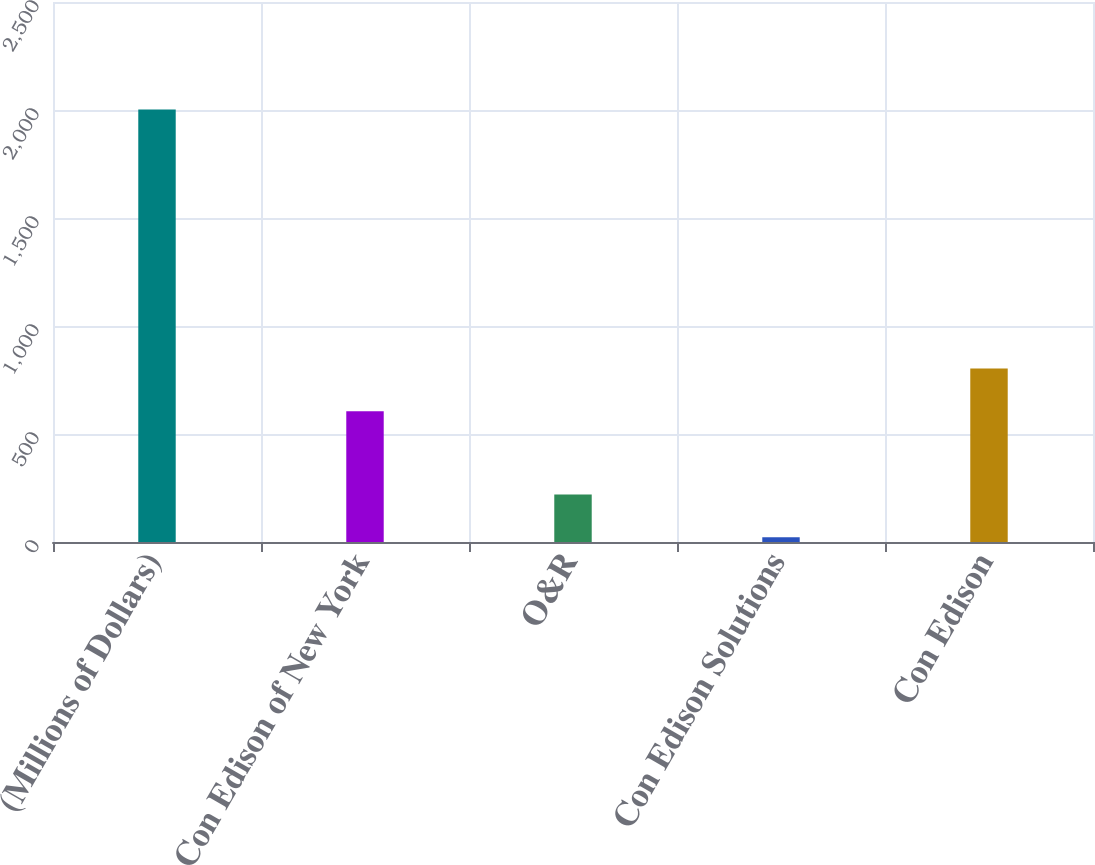Convert chart to OTSL. <chart><loc_0><loc_0><loc_500><loc_500><bar_chart><fcel>(Millions of Dollars)<fcel>Con Edison of New York<fcel>O&R<fcel>Con Edison Solutions<fcel>Con Edison<nl><fcel>2002<fcel>605<fcel>220<fcel>22<fcel>803<nl></chart> 